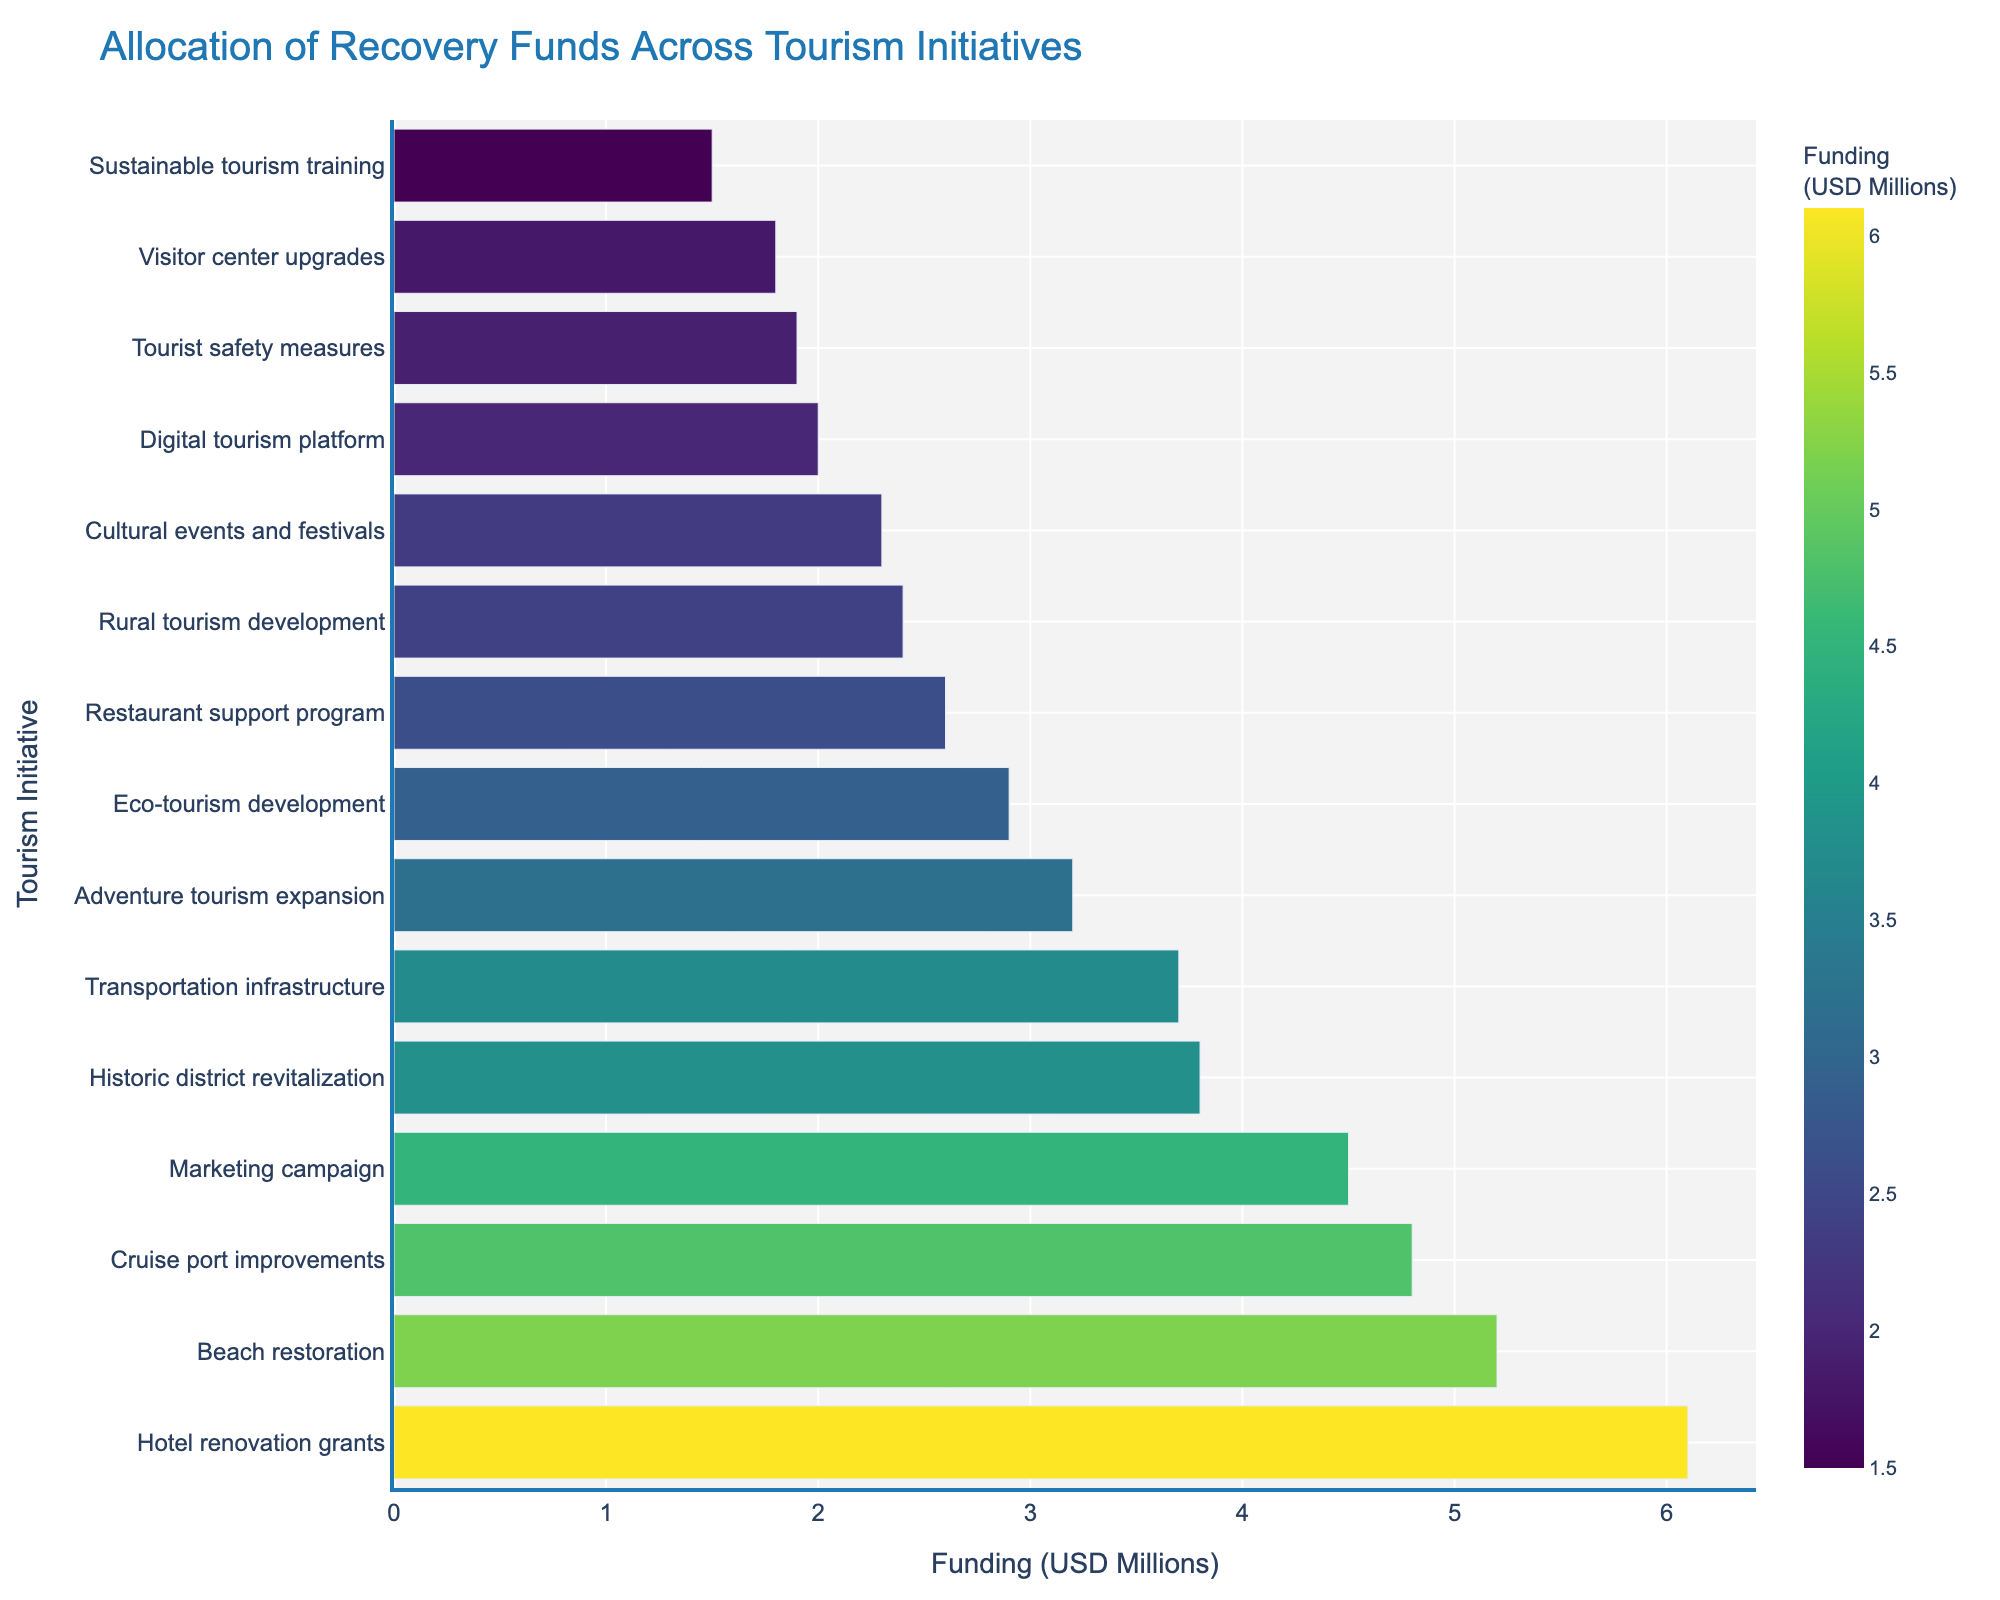Which tourism initiative received the most funding? By observing the length of the bars, we can see the longest bar corresponds to "Hotel renovation grants" which received the highest funding amount.
Answer: Hotel renovation grants What is the total funding allocated to Beach restoration, Cultural events and festivals, and Digital tourism platform? Add the funding amounts for each of these initiatives: Beach restoration (5.2), Cultural events and festivals (2.3), and Digital tourism platform (2.0). Their total is 5.2 + 2.3 + 2.0 = 9.5 million USD.
Answer: 9.5 million USD How does the funding for the Marketing campaign compare to the funding for Eco-tourism development? By comparing the lengths of the bars, we see that the Marketing campaign received 4.5 million USD and Eco-tourism development received 2.9 million USD. The funding for the Marketing campaign is 1.6 million USD greater than that for Eco-tourism development.
Answer: Marketing campaign received 1.6 million USD more Which initiatives received funding between 2 and 3 million USD? Looking at the bars whose lengths place them in the 2 to 3 million USD range, we identify Eco-tourism development (2.9), Restaurant support program (2.6), Rural tourism development (2.4), Cultural events and festivals (2.3), and Digital tourism platform (2.0).
Answer: Eco-tourism development, Restaurant support program, Rural tourism development, Cultural events and festivals, Digital tourism platform What is the combined funding for initiatives related to infrastructure (Transportation infrastructure and Cruise port improvements)? Add the funding amounts for Transportation infrastructure (3.7) and Cruise port improvements (4.8). Their combined funding is 3.7 + 4.8 = 8.5 million USD.
Answer: 8.5 million USD Which initiative is immediately below Beach restoration in terms of funding? The bar immediately below Beach restoration belongs to Cruise port improvements, meaning it received the next highest amount of funding after Beach restoration.
Answer: Cruise port improvements How much more funding does Hotel renovation grants receive compared to Tourist safety measures? Subtract the funding for Tourist safety measures (1.9) from that for Hotel renovation grants (6.1). The difference is 6.1 - 1.9 = 4.2 million USD.
Answer: 4.2 million USD What is the median funding amount among all the initiatives? Arrange the funding amounts in numerical order: 1.5, 1.8, 1.9, 2.0, 2.3, 2.4, 2.6, 2.9, 3.2, 3.7, 3.8, 4.5, 4.8, 5.2, 6.1. The median is the middle value in this ordered list, which is 2.9 million USD.
Answer: 2.9 million USD Which initiative has the second smallest amount of funding? By observing the smallest bars, we see the second smallest one corresponds to "Visitor center upgrades" with funding of 1.8 million USD.
Answer: Visitor center upgrades 